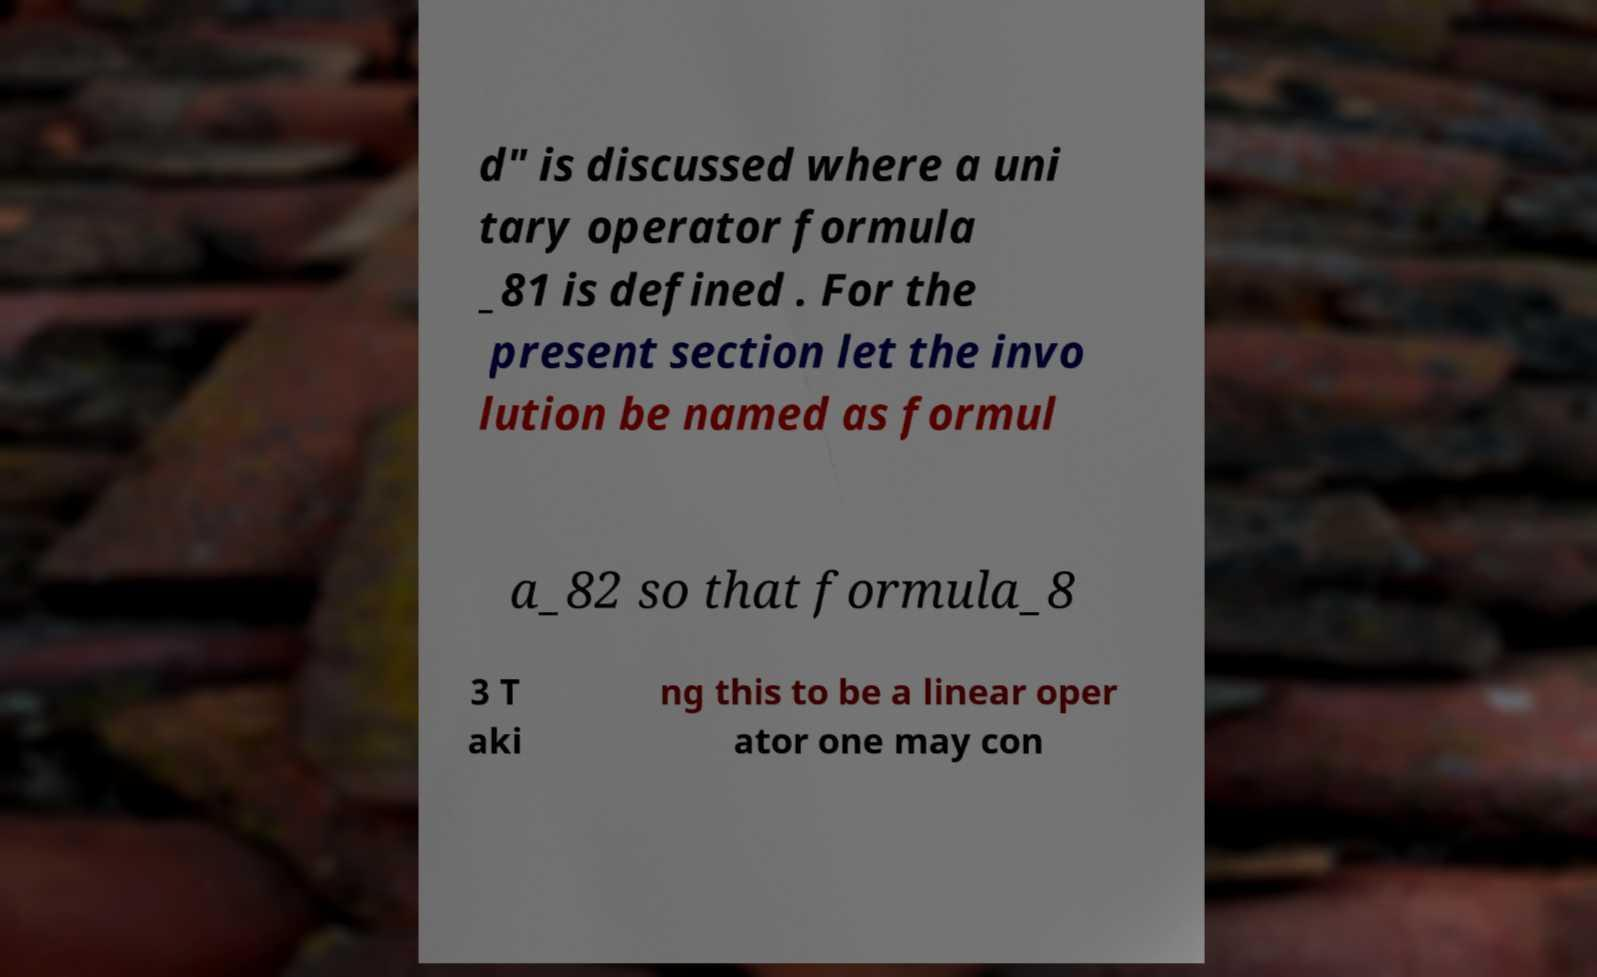For documentation purposes, I need the text within this image transcribed. Could you provide that? d" is discussed where a uni tary operator formula _81 is defined . For the present section let the invo lution be named as formul a_82 so that formula_8 3 T aki ng this to be a linear oper ator one may con 